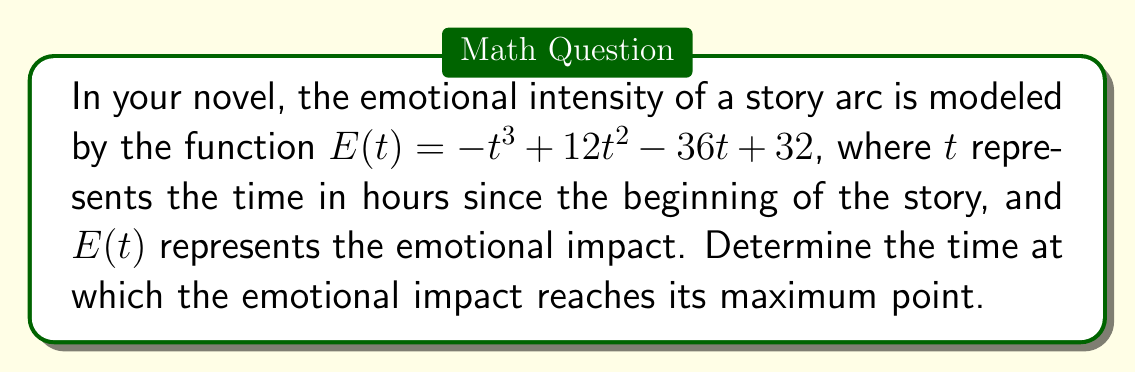Provide a solution to this math problem. To find the maximum point of the emotional impact, we need to follow these steps:

1) First, we need to find the derivative of $E(t)$:
   $E'(t) = -3t^2 + 24t - 36$

2) The maximum point occurs where the derivative equals zero. So, we set $E'(t) = 0$:
   $-3t^2 + 24t - 36 = 0$

3) This is a quadratic equation. We can solve it using the quadratic formula:
   $t = \frac{-b \pm \sqrt{b^2 - 4ac}}{2a}$

   Where $a = -3$, $b = 24$, and $c = -36$

4) Substituting these values:
   $t = \frac{-24 \pm \sqrt{24^2 - 4(-3)(-36)}}{2(-3)}$
   $= \frac{-24 \pm \sqrt{576 - 432}}{-6}$
   $= \frac{-24 \pm \sqrt{144}}{-6}$
   $= \frac{-24 \pm 12}{-6}$

5) This gives us two solutions:
   $t_1 = \frac{-24 + 12}{-6} = 2$
   $t_2 = \frac{-24 - 12}{-6} = 6$

6) To determine which of these is the maximum point, we can check the second derivative:
   $E''(t) = -6t + 24$

7) At $t = 2$: $E''(2) = -6(2) + 24 = 12 > 0$
   At $t = 6$: $E''(6) = -6(6) + 24 = -12 < 0$

8) Since the second derivative is negative at $t = 6$, this is the maximum point.

Therefore, the emotional impact reaches its maximum point at 6 hours into the story.
Answer: 6 hours 